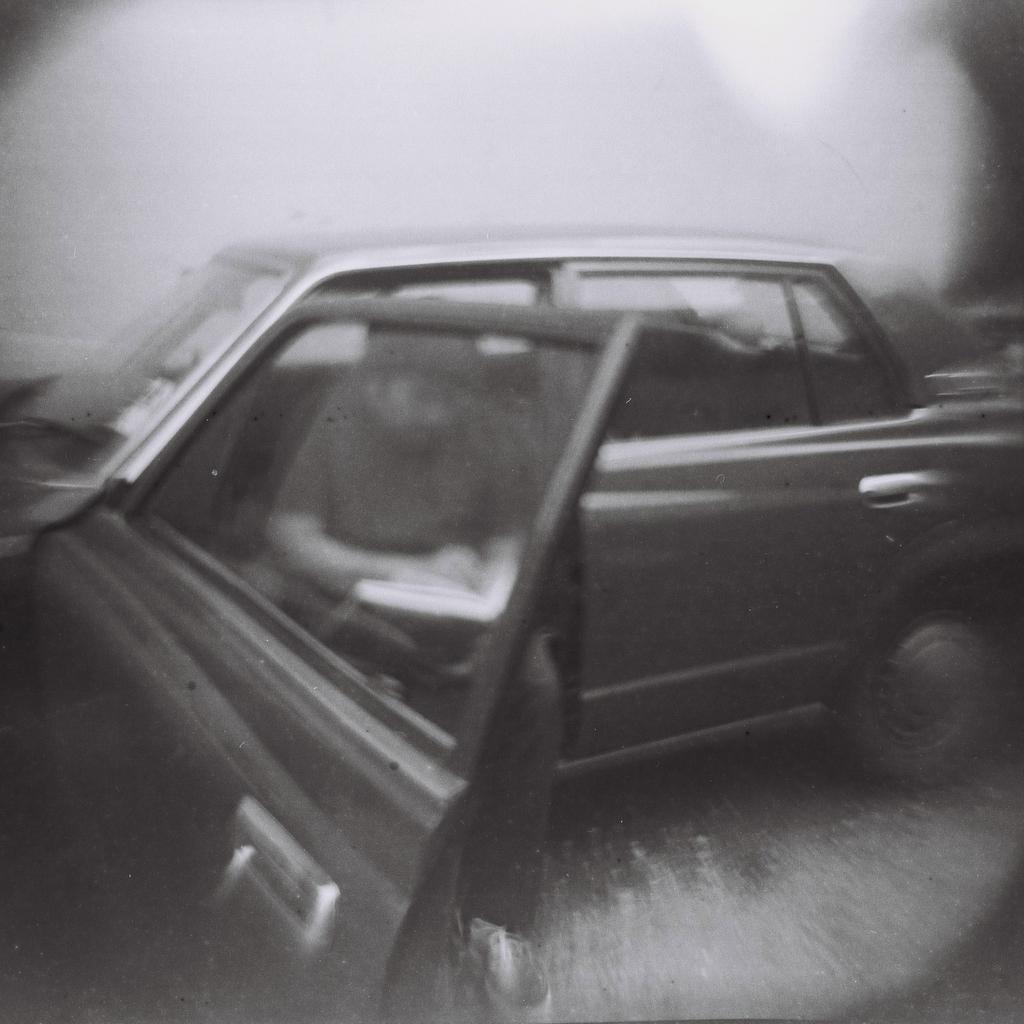In one or two sentences, can you explain what this image depicts? In this image in the center there is a car and there is a person sitting in the car holding a book in his hand. 